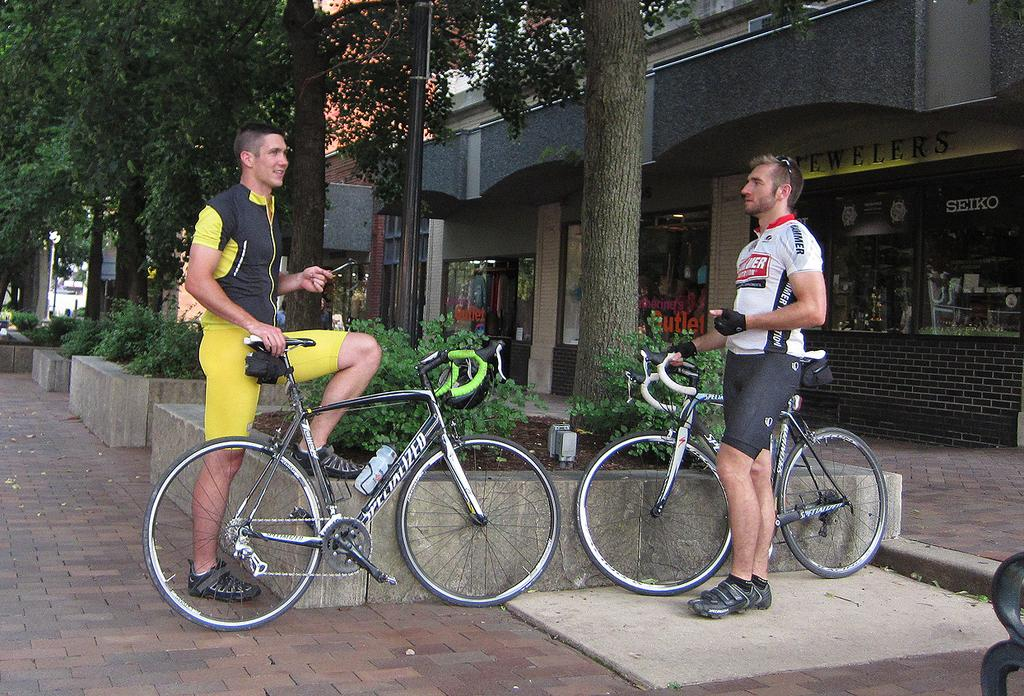How many people are in the image? There are two people in the image. What are the people doing in the image? The people are standing and holding bicycles. What type of vegetation can be seen in the image? There are plants and trees visible in the image. What type of structures can be seen in the image? There are buildings in the image. What grade is the cemetery in the image? There is no cemetery present in the image. What direction is the sun shining from in the image? The provided facts do not mention the sun or its position in the image. 